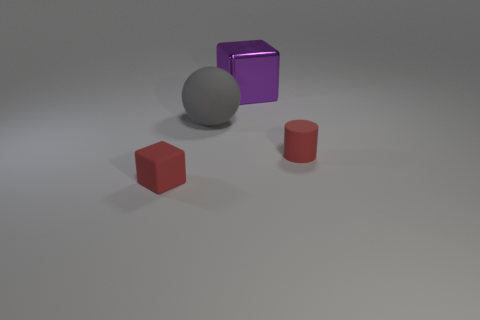Add 3 red matte cylinders. How many objects exist? 7 Subtract all balls. How many objects are left? 3 Add 4 gray matte spheres. How many gray matte spheres are left? 5 Add 1 big cyan rubber blocks. How many big cyan rubber blocks exist? 1 Subtract 0 brown blocks. How many objects are left? 4 Subtract all cylinders. Subtract all small red cylinders. How many objects are left? 2 